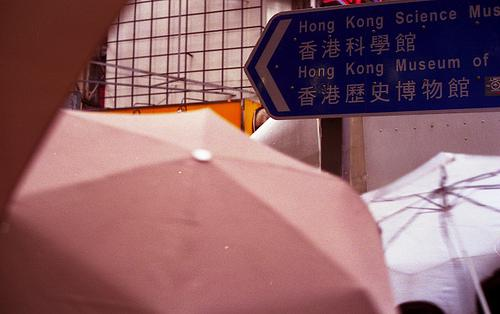What sentiment could this image evoke in a viewer? The image could evoke curiosity and interest in exploring the nearby museum, with a hint of a rainy atmosphere due to the presence of umbrellas. Describe the appearance of the wall where the sign is located. The wall has an orange lower half and a textured white top part. What details are present on the sign in regards to the Hong Kong Science Museum? The sign says "Hong Kong Science Museum" in English and Chinese characters, with white lettering and an arrow pointing towards the museum. What type of establishments does the sign provide directions to, and where is it located? The sign points towards the Hong Kong Science Museum and is located in Hong Kong. Identify the main object in the image and provide a brief description of its appearance. The main object is a blue and white street sign on the wall, featuring white lettering and arrow, and Chinese characters, indicating directions to the Hong Kong Science Museum. Count the total number of umbrellas in the image and provide a description of their colors and features. There are three umbrellas in the image - a brown one in the front, a pink one that is open, and a white one next to the pink one. The white umbrella has a cap on top. Describe the scene related to people and their accessories in the image. People are carrying umbrellas over their heads, with a brown umbrella in front, a pink open umbrella, and a white umbrella next to the pink one. What language is used on the street sign, and what type of script is used for the non-English text? The street sign has both English and Chinese text, with Chinese characters for the non-English script. Name some unique features of the umbrellas in the image. The brown umbrella is in front, the pink umbrella is open, the white umbrella has a cap on top, and the handle of one umbrella is silver. How would you describe the quality of the image? The image is well-composed, clear, and contains sufficient details to understand the scene, making it a high-quality image. 